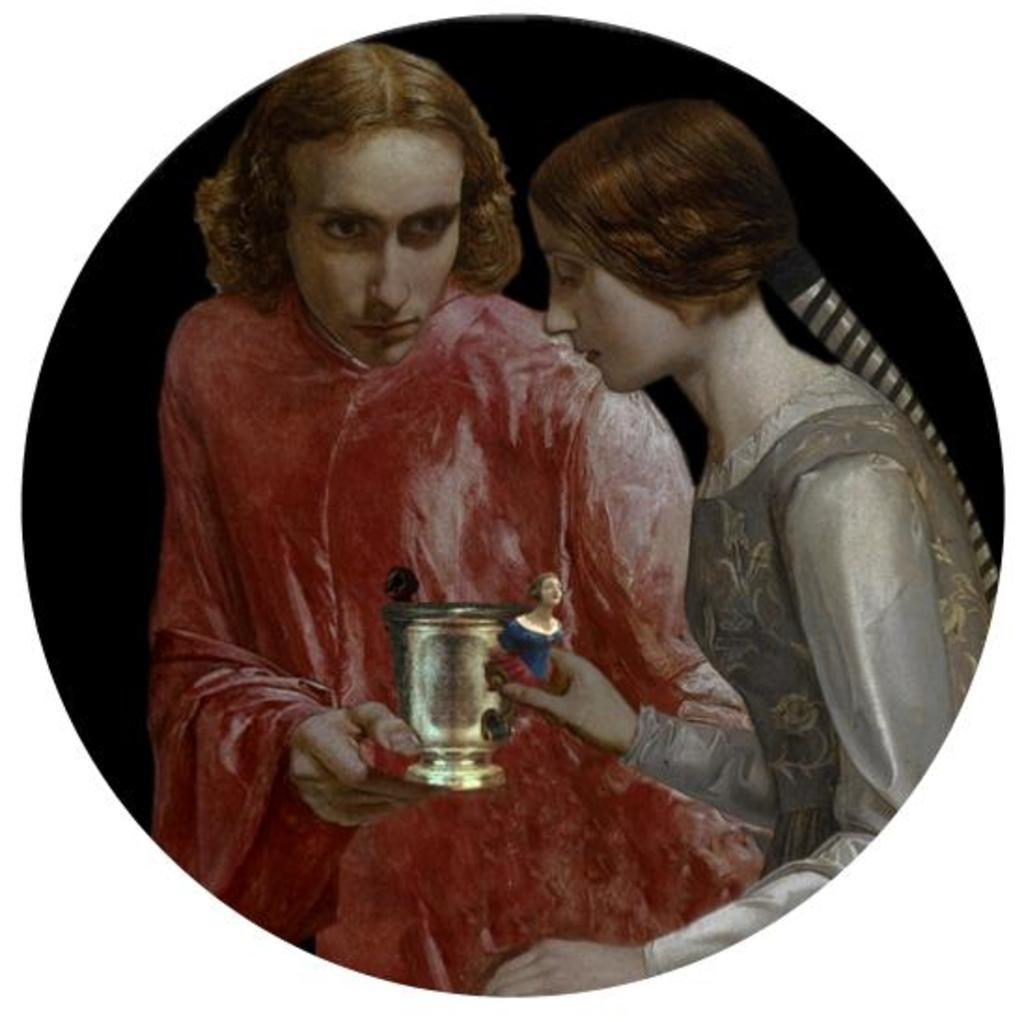In one or two sentences, can you explain what this image depicts? In this image, we can see a painting. Here we can see two people are holding some object. 